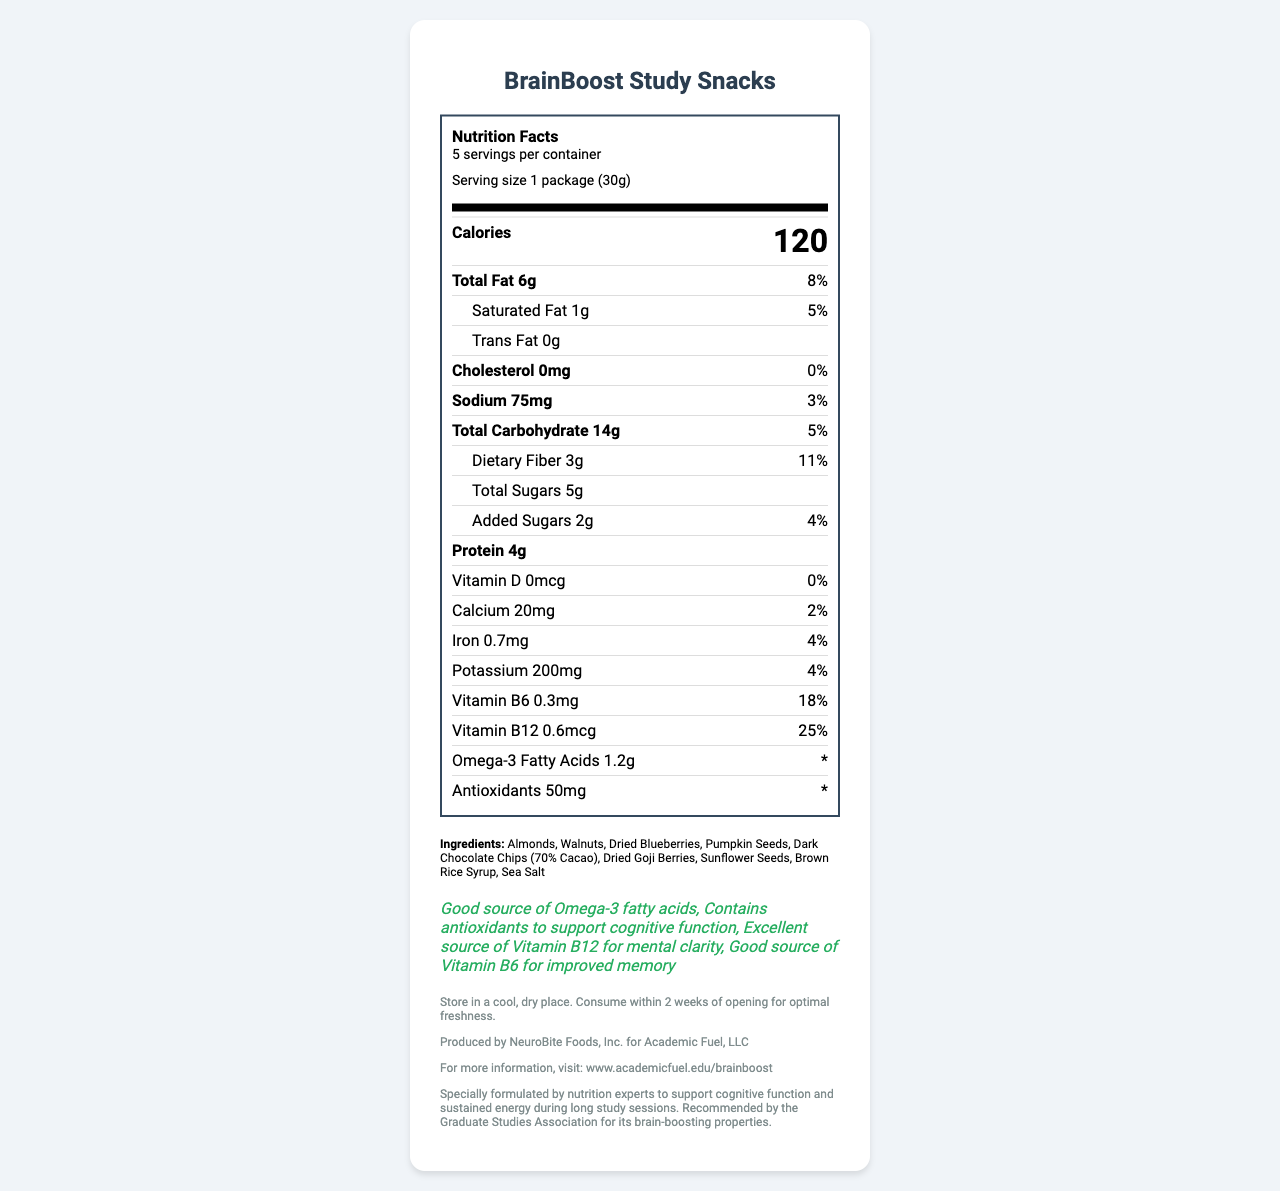What is the serving size of BrainBoost Study Snacks? The serving size information is stated clearly in the document under the serving information section.
Answer: 1 package (30g) How many calories are in one serving of BrainBoost Study Snacks? The document lists the calorie content per serving prominently under the "Calories" section.
Answer: 120 What percentage of the daily value of Vitamin B12 does BrainBoost Study Snacks provide per serving? The document shows the daily value percentages for nutrients, with Vitamin B12 listed as 25% per serving.
Answer: 25% List three ingredients in BrainBoost Study Snacks. The ingredients are listed in the Ingredients section of the document.
Answer: Almonds, Walnuts, Dried Blueberries How much protein is in a serving of BrainBoost Study Snacks? The protein content is shown in the nutrient section.
Answer: 4g What health claim is made about antioxidants in BrainBoost Study Snacks? This information is noted in the health claims section.
Answer: Contains antioxidants to support cognitive function What is the recommended storage instruction for BrainBoost Study Snacks? The storage instructions are listed under the additional information section.
Answer: Store in a cool, dry place. Consume within 2 weeks of opening for optimal freshness. Does BrainBoost Study Snacks contain any tree nuts? The allergen information mentions that the product contains tree nuts (Almonds, Walnuts).
Answer: Yes Which of the following nutrients has the highest percentage of daily value in BrainBoost Study Snacks? 
A. Vitamin B6 
B. Iron 
C. Vitamin B12 
D. Omega-3 Fatty Acids The document lists Vitamin B12 with the highest daily value at 25%, compared to Vitamin B6 (18%), Iron (4%), and Omega-3 Fatty Acids (* with no specific daily value).
Answer: C. Vitamin B12 Which ingredient in BrainBoost Study Snacks is listed as potentially allergenic?  
A. Almonds 
B. Walnuts 
C. Sunflower Seeds 
D. Dried Blueberries Both Almonds and Walnuts are listed as tree nuts, which are potential allergens.
Answer: A, B Does BrainBoost Study Snacks contain any cholesterol? The cholesterol content is listed as 0mg.
Answer: No Summarize the main information provided about BrainBoost Study Snacks. The explanation summarizes nutrient values, ingredients, health claims, allergen information, and additional details provided in the document.
Answer: BrainBoost Study Snacks is a brain-boosting snack designed to enhance study sessions. It includes a variety of nutrients per 30g serving, such as 120 calories, 6g of total fat, and 4g of protein. It contains multiple ingredients like almonds, walnuts, and dark chocolate chips, with specific health claims including Omega-3 fatty acids and support for cognitive function. It also highlights allergen information, storage instructions, and manufacturer details. How much dietary fiber do BrainBoost Study Snacks contain? The dietary fiber content is listed specifically under the nutrient information.
Answer: 3g What is the amount of added sugars in BrainBoost Study Snacks? The document lists the added sugars under the nutrient details.
Answer: 2g Who produces BrainBoost Study Snacks? The manufacturer information section provides this detail.
Answer: NeuroBite Foods, Inc. for Academic Fuel, LLC What is the percentage of daily value for calcium in BrainBoost Study Snacks? The calcium percentage is shown in the detailed nutrient section.
Answer: 2% Does BrainBoost Study Snacks mention specific benefits for memory in the health claims? The health claims mention that Vitamin B6 is a good source for improved memory.
Answer: Yes When should BrainBoost Study Snacks be consumed after opening? The storage instructions recommend consuming the product within 2 weeks of opening for optimal freshness.
Answer: Within 2 weeks Can you find information about the price of BrainBoost Study Snacks in the document? The document does not contain any information regarding the price of the product.
Answer: I don't know What percentage of the daily value of dietary fiber does one serving of BrainBoost Study Snacks provide? This information is provided in the nutrient section under dietary fiber.
Answer: 11% What website can you visit for more information about BrainBoost Study Snacks? The document lists this website under the additional information section.
Answer: www.academicfuel.edu/brainboost 